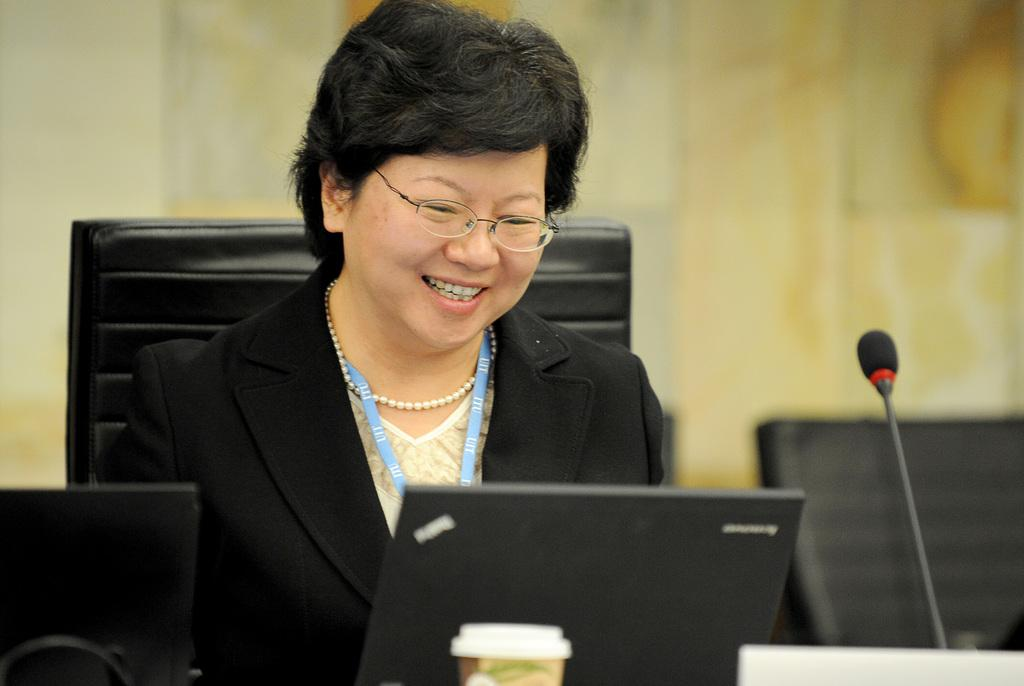What objects are located at the bottom of the image? There are laptops, a microphone, and a cup at the bottom of the image. What is the woman in the image doing? The woman is sitting on a chair in the image. What is the woman's facial expression? The woman is smiling. How would you describe the background of the image? The background of the image is blurred. What advice is the woman giving to the structure in the image? There is no structure present in the image, and the woman is not giving any advice. How high does the woman jump in the image? The woman is sitting on a chair in the image and is not jumping. 